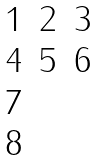<formula> <loc_0><loc_0><loc_500><loc_500>\begin{matrix} 1 & 2 & 3 \\ 4 & 5 & 6 \\ 7 & & \\ 8 & & \end{matrix}</formula> 